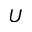<formula> <loc_0><loc_0><loc_500><loc_500>U</formula> 